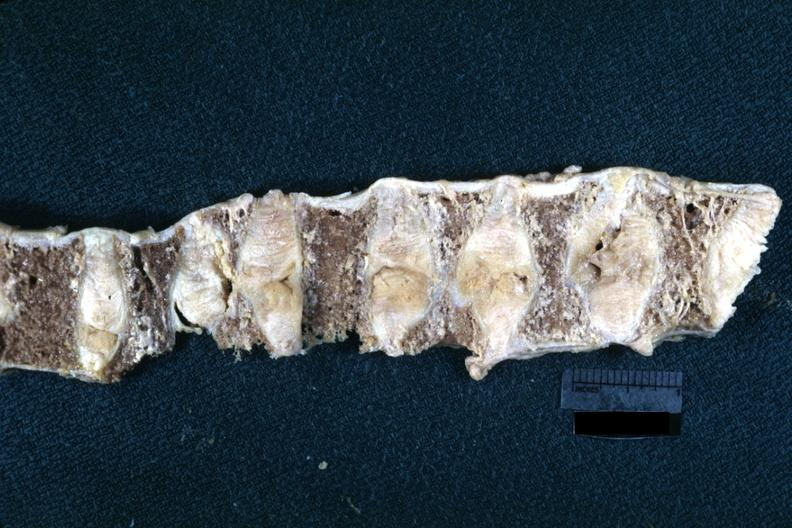how is this lesion probably to osteoporosis?
Answer the question using a single word or phrase. Due 